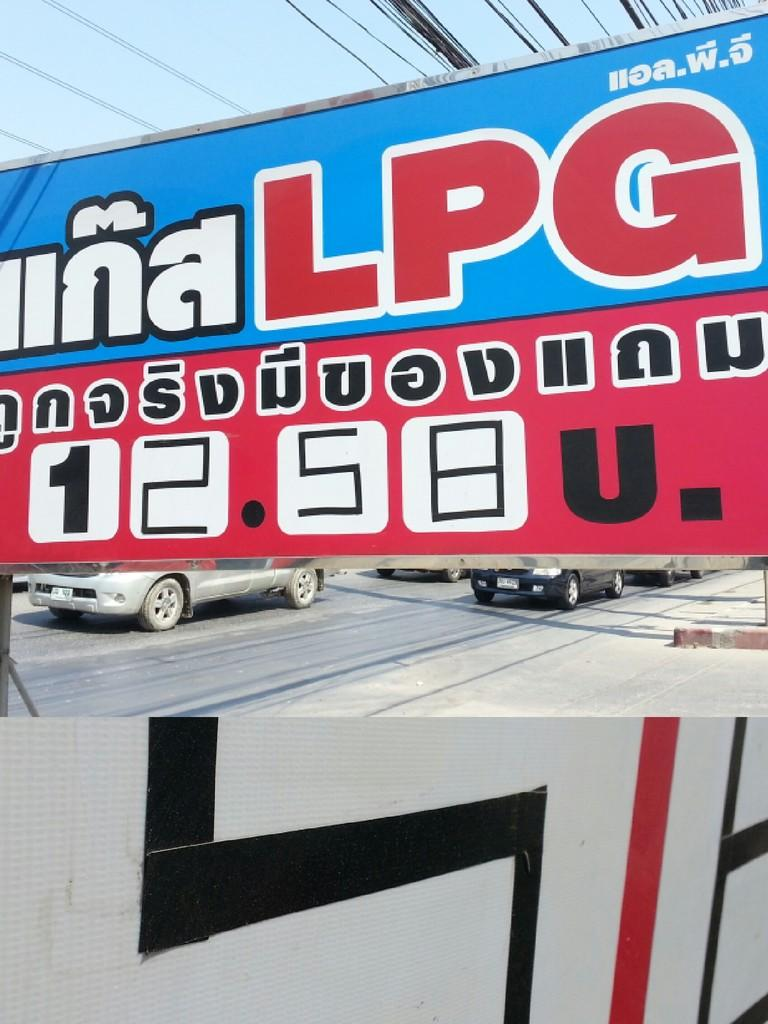What is hanging in the image? There is a banner in the image. What can be read on the banner? There is text written on the banner. What is happening in the background of the image? There are cars on the road in the image. Are there any other banners in the image? Yes, there is another banner in the image. What is written on the second banner? There is text on the second banner. What type of holiday decoration is hanging from the sister's hair in the image? There is no mention of a sister or any holiday decorations in the image; it only features banners with text and cars on the road. 